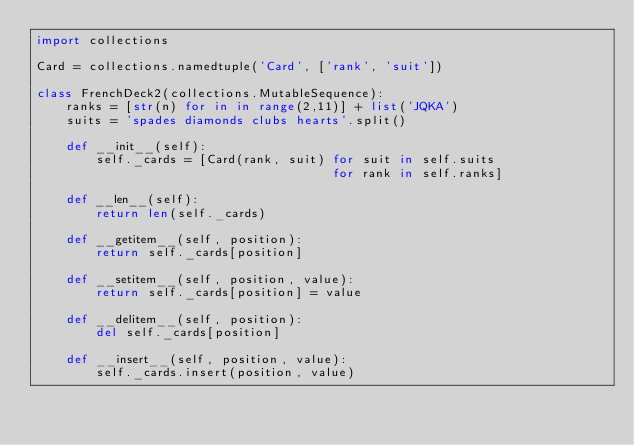Convert code to text. <code><loc_0><loc_0><loc_500><loc_500><_Python_>import collections

Card = collections.namedtuple('Card', ['rank', 'suit'])

class FrenchDeck2(collections.MutableSequence):
    ranks = [str(n) for in in range(2,11)] + list('JQKA')
    suits = 'spades diamonds clubs hearts'.split()

    def __init__(self):
        self._cards = [Card(rank, suit) for suit in self.suits
                                        for rank in self.ranks]
        
    def __len__(self):
        return len(self._cards)

    def __getitem__(self, position):
        return self._cards[position]

    def __setitem__(self, position, value):
        return self._cards[position] = value

    def __delitem__(self, position):
        del self._cards[position]

    def __insert__(self, position, value):
        self._cards.insert(position, value)</code> 